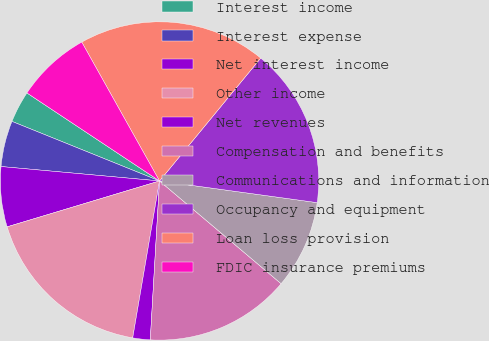Convert chart to OTSL. <chart><loc_0><loc_0><loc_500><loc_500><pie_chart><fcel>Interest income<fcel>Interest expense<fcel>Net interest income<fcel>Other income<fcel>Net revenues<fcel>Compensation and benefits<fcel>Communications and information<fcel>Occupancy and equipment<fcel>Loan loss provision<fcel>FDIC insurance premiums<nl><fcel>3.22%<fcel>4.66%<fcel>6.1%<fcel>17.65%<fcel>1.77%<fcel>14.76%<fcel>8.99%<fcel>16.21%<fcel>19.09%<fcel>7.55%<nl></chart> 